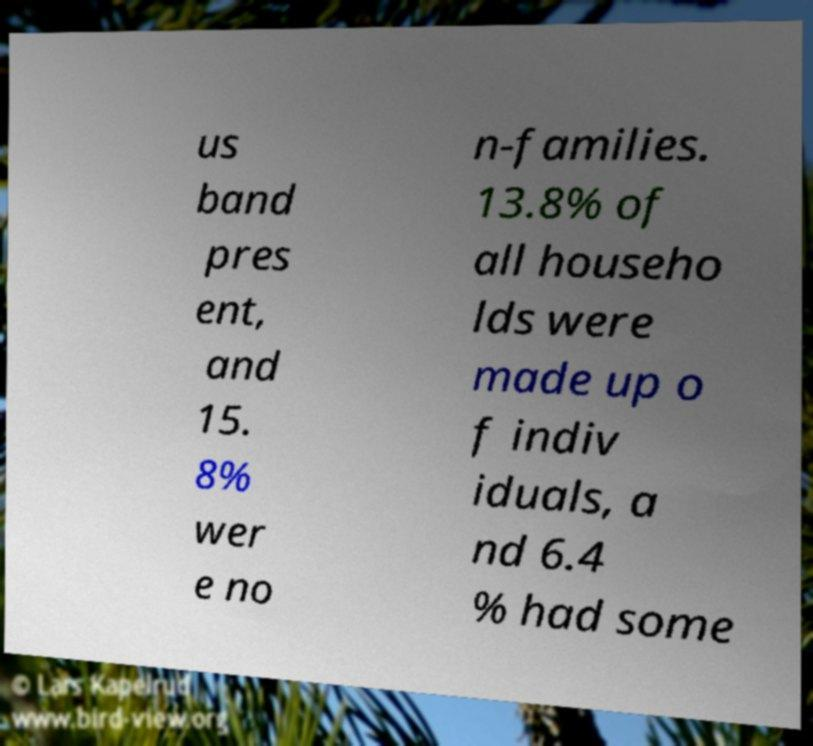Could you assist in decoding the text presented in this image and type it out clearly? us band pres ent, and 15. 8% wer e no n-families. 13.8% of all househo lds were made up o f indiv iduals, a nd 6.4 % had some 